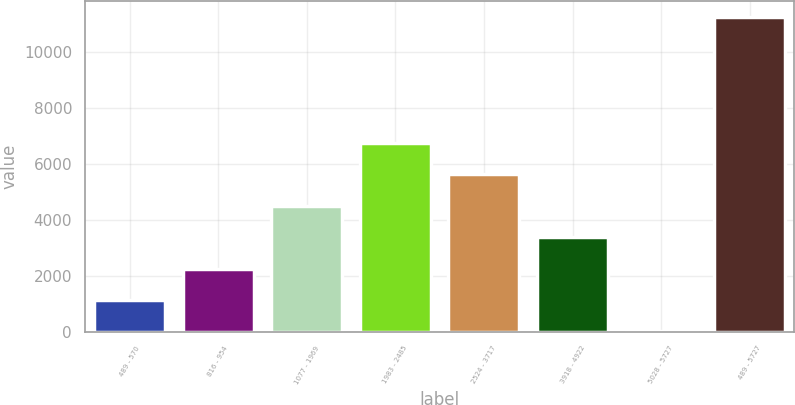Convert chart to OTSL. <chart><loc_0><loc_0><loc_500><loc_500><bar_chart><fcel>489 - 570<fcel>816 - 954<fcel>1077 - 1969<fcel>1983 - 2485<fcel>2524 - 3717<fcel>3918 - 4922<fcel>5028 - 5727<fcel>489 - 5727<nl><fcel>1133.6<fcel>2257.2<fcel>4504.4<fcel>6751.6<fcel>5628<fcel>3380.8<fcel>10<fcel>11246<nl></chart> 